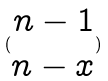Convert formula to latex. <formula><loc_0><loc_0><loc_500><loc_500>( \begin{matrix} n - 1 \\ n - x \end{matrix} )</formula> 